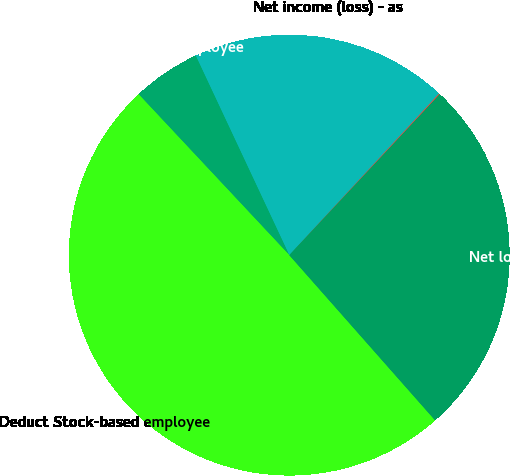Convert chart to OTSL. <chart><loc_0><loc_0><loc_500><loc_500><pie_chart><fcel>Net income (loss) - as<fcel>Add Stock-based employee<fcel>Deduct Stock-based employee<fcel>Net loss - pro forma<fcel>Basic<nl><fcel>18.88%<fcel>5.0%<fcel>49.53%<fcel>26.54%<fcel>0.05%<nl></chart> 